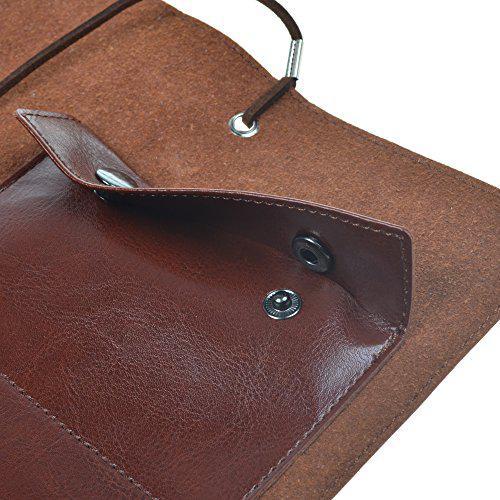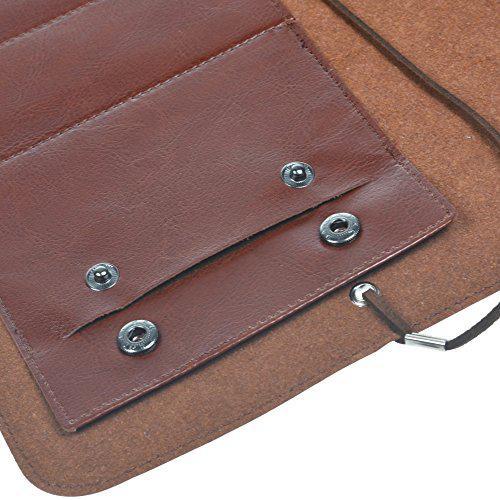The first image is the image on the left, the second image is the image on the right. For the images displayed, is the sentence "The left image shows one filled brown leather pencil case opened and right-side up, and the right image contains no more than two pencil cases." factually correct? Answer yes or no. No. The first image is the image on the left, the second image is the image on the right. Assess this claim about the two images: "there is a brown Swede pencil pouch open and displaying 5 pockets , the pockets have pens and pencils and there is a leather strap attached". Correct or not? Answer yes or no. No. 